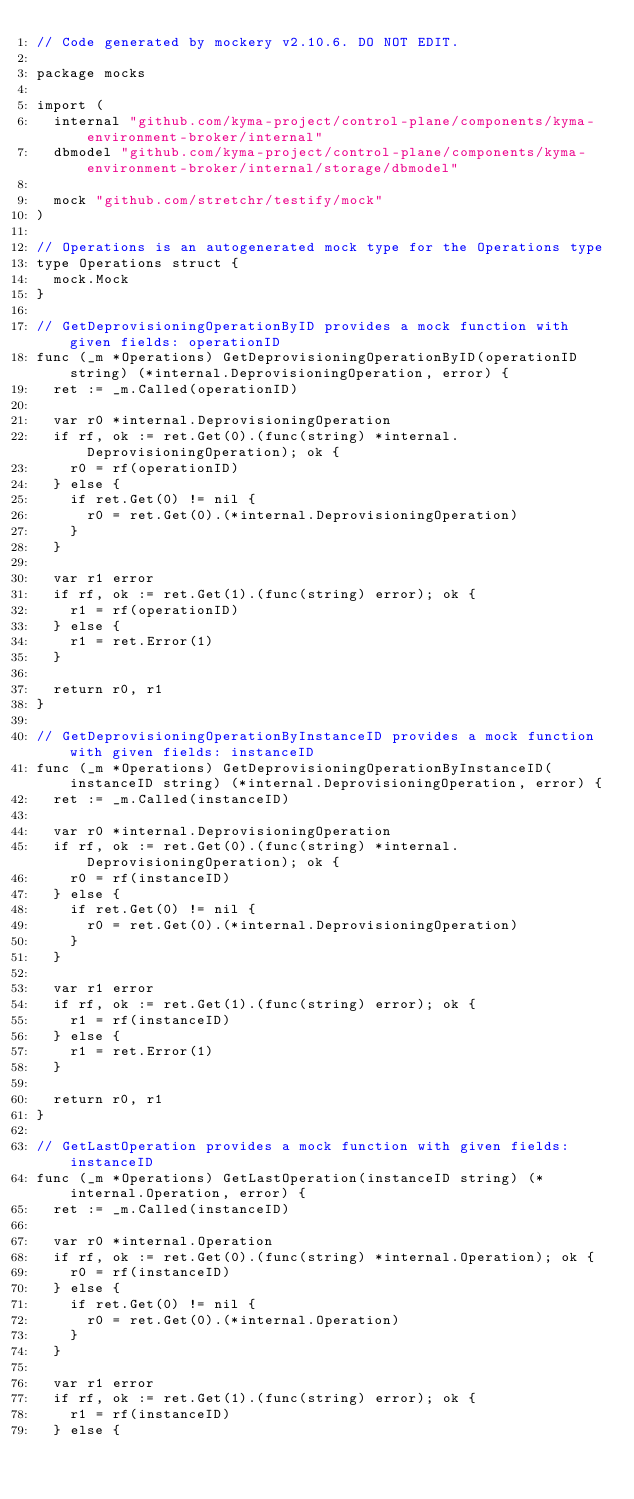<code> <loc_0><loc_0><loc_500><loc_500><_Go_>// Code generated by mockery v2.10.6. DO NOT EDIT.

package mocks

import (
	internal "github.com/kyma-project/control-plane/components/kyma-environment-broker/internal"
	dbmodel "github.com/kyma-project/control-plane/components/kyma-environment-broker/internal/storage/dbmodel"

	mock "github.com/stretchr/testify/mock"
)

// Operations is an autogenerated mock type for the Operations type
type Operations struct {
	mock.Mock
}

// GetDeprovisioningOperationByID provides a mock function with given fields: operationID
func (_m *Operations) GetDeprovisioningOperationByID(operationID string) (*internal.DeprovisioningOperation, error) {
	ret := _m.Called(operationID)

	var r0 *internal.DeprovisioningOperation
	if rf, ok := ret.Get(0).(func(string) *internal.DeprovisioningOperation); ok {
		r0 = rf(operationID)
	} else {
		if ret.Get(0) != nil {
			r0 = ret.Get(0).(*internal.DeprovisioningOperation)
		}
	}

	var r1 error
	if rf, ok := ret.Get(1).(func(string) error); ok {
		r1 = rf(operationID)
	} else {
		r1 = ret.Error(1)
	}

	return r0, r1
}

// GetDeprovisioningOperationByInstanceID provides a mock function with given fields: instanceID
func (_m *Operations) GetDeprovisioningOperationByInstanceID(instanceID string) (*internal.DeprovisioningOperation, error) {
	ret := _m.Called(instanceID)

	var r0 *internal.DeprovisioningOperation
	if rf, ok := ret.Get(0).(func(string) *internal.DeprovisioningOperation); ok {
		r0 = rf(instanceID)
	} else {
		if ret.Get(0) != nil {
			r0 = ret.Get(0).(*internal.DeprovisioningOperation)
		}
	}

	var r1 error
	if rf, ok := ret.Get(1).(func(string) error); ok {
		r1 = rf(instanceID)
	} else {
		r1 = ret.Error(1)
	}

	return r0, r1
}

// GetLastOperation provides a mock function with given fields: instanceID
func (_m *Operations) GetLastOperation(instanceID string) (*internal.Operation, error) {
	ret := _m.Called(instanceID)

	var r0 *internal.Operation
	if rf, ok := ret.Get(0).(func(string) *internal.Operation); ok {
		r0 = rf(instanceID)
	} else {
		if ret.Get(0) != nil {
			r0 = ret.Get(0).(*internal.Operation)
		}
	}

	var r1 error
	if rf, ok := ret.Get(1).(func(string) error); ok {
		r1 = rf(instanceID)
	} else {</code> 